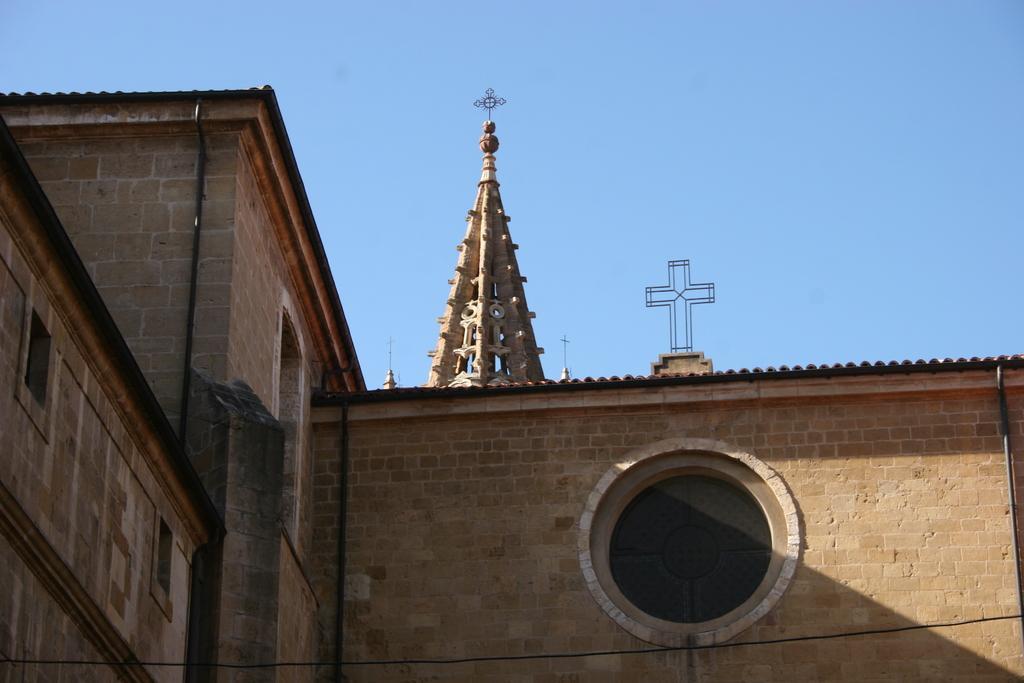Please provide a concise description of this image. In the image we can see stone wall, cross symbol and the sky. 